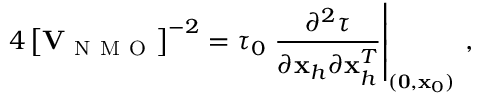<formula> <loc_0><loc_0><loc_500><loc_500>4 \left [ { V } _ { N M O } \right ] ^ { - 2 } = \tau _ { 0 } \frac { \partial ^ { 2 } \tau } { \partial { x } _ { h } \partial { x } _ { h } ^ { T } } \right | _ { ( { 0 } , { x } _ { 0 } ) } \, ,</formula> 